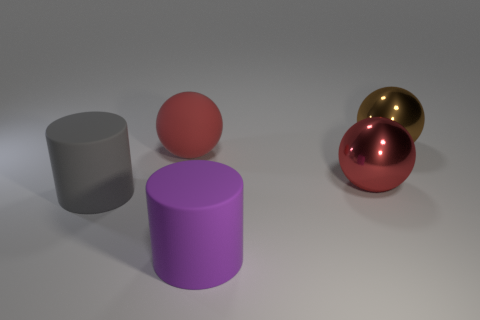Subtract all brown metal balls. How many balls are left? 2 Subtract all brown spheres. How many spheres are left? 2 Subtract all spheres. How many objects are left? 2 Subtract all blue blocks. How many gray cylinders are left? 1 Add 5 small blue rubber cylinders. How many small blue rubber cylinders exist? 5 Add 2 large red rubber balls. How many objects exist? 7 Subtract 1 purple cylinders. How many objects are left? 4 Subtract 1 cylinders. How many cylinders are left? 1 Subtract all cyan balls. Subtract all blue cubes. How many balls are left? 3 Subtract all large rubber objects. Subtract all metal objects. How many objects are left? 0 